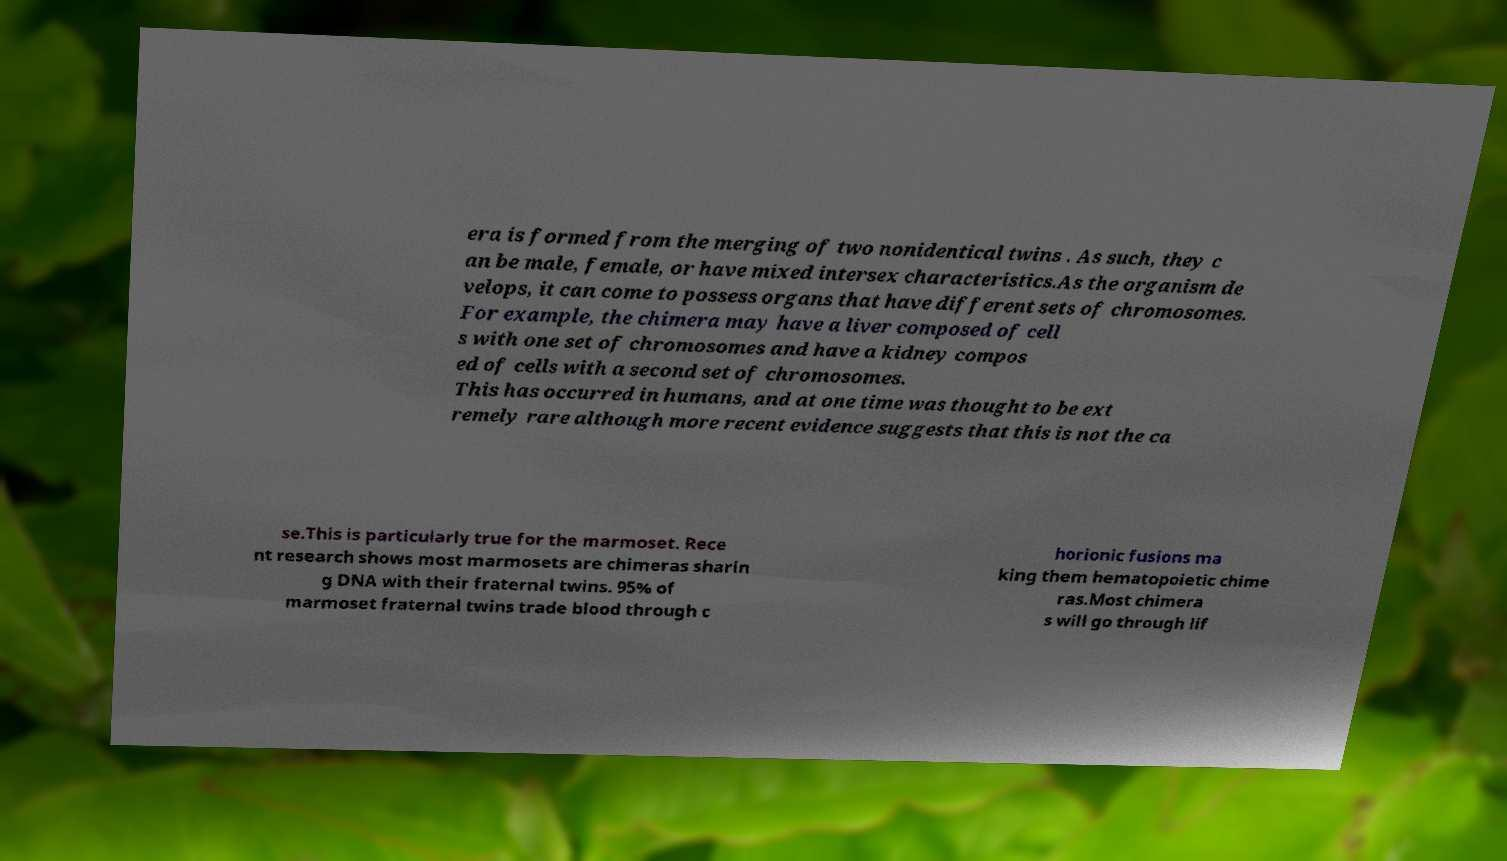Can you read and provide the text displayed in the image?This photo seems to have some interesting text. Can you extract and type it out for me? era is formed from the merging of two nonidentical twins . As such, they c an be male, female, or have mixed intersex characteristics.As the organism de velops, it can come to possess organs that have different sets of chromosomes. For example, the chimera may have a liver composed of cell s with one set of chromosomes and have a kidney compos ed of cells with a second set of chromosomes. This has occurred in humans, and at one time was thought to be ext remely rare although more recent evidence suggests that this is not the ca se.This is particularly true for the marmoset. Rece nt research shows most marmosets are chimeras sharin g DNA with their fraternal twins. 95% of marmoset fraternal twins trade blood through c horionic fusions ma king them hematopoietic chime ras.Most chimera s will go through lif 